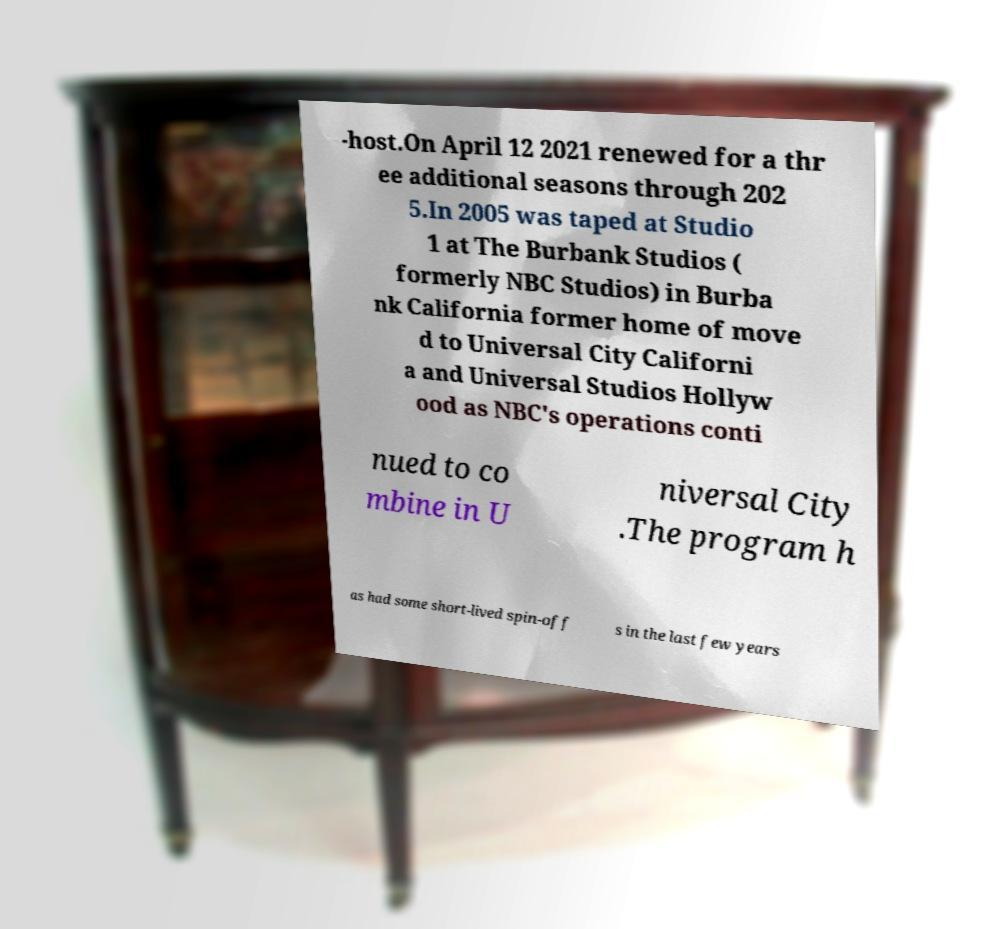Could you assist in decoding the text presented in this image and type it out clearly? -host.On April 12 2021 renewed for a thr ee additional seasons through 202 5.In 2005 was taped at Studio 1 at The Burbank Studios ( formerly NBC Studios) in Burba nk California former home of move d to Universal City Californi a and Universal Studios Hollyw ood as NBC's operations conti nued to co mbine in U niversal City .The program h as had some short-lived spin-off s in the last few years 